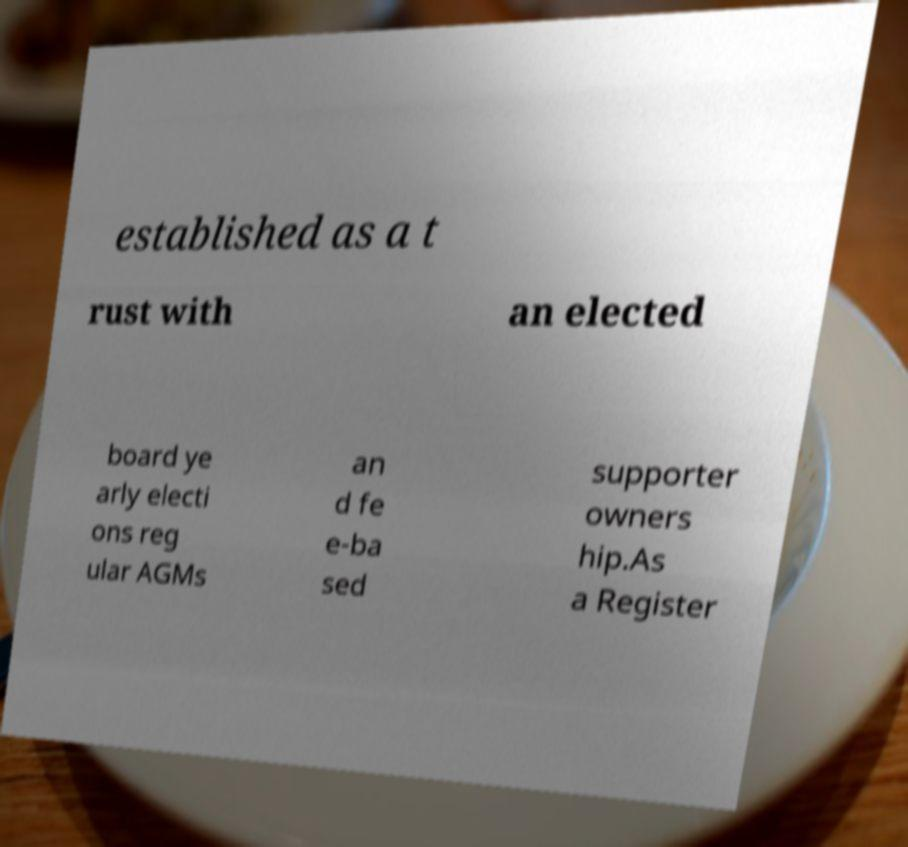Could you assist in decoding the text presented in this image and type it out clearly? established as a t rust with an elected board ye arly electi ons reg ular AGMs an d fe e-ba sed supporter owners hip.As a Register 